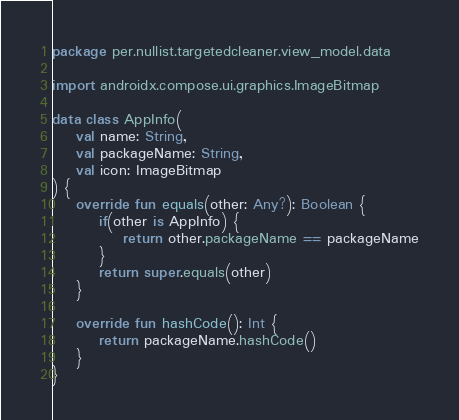<code> <loc_0><loc_0><loc_500><loc_500><_Kotlin_>package per.nullist.targetedcleaner.view_model.data

import androidx.compose.ui.graphics.ImageBitmap

data class AppInfo(
    val name: String,
    val packageName: String,
    val icon: ImageBitmap
) {
    override fun equals(other: Any?): Boolean {
        if(other is AppInfo) {
            return other.packageName == packageName
        }
        return super.equals(other)
    }

    override fun hashCode(): Int {
        return packageName.hashCode()
    }
}
</code> 